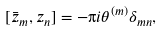Convert formula to latex. <formula><loc_0><loc_0><loc_500><loc_500>[ \bar { z } _ { m } , z _ { n } ] = - \i i \theta ^ { ( m ) } \delta _ { m n } ,</formula> 